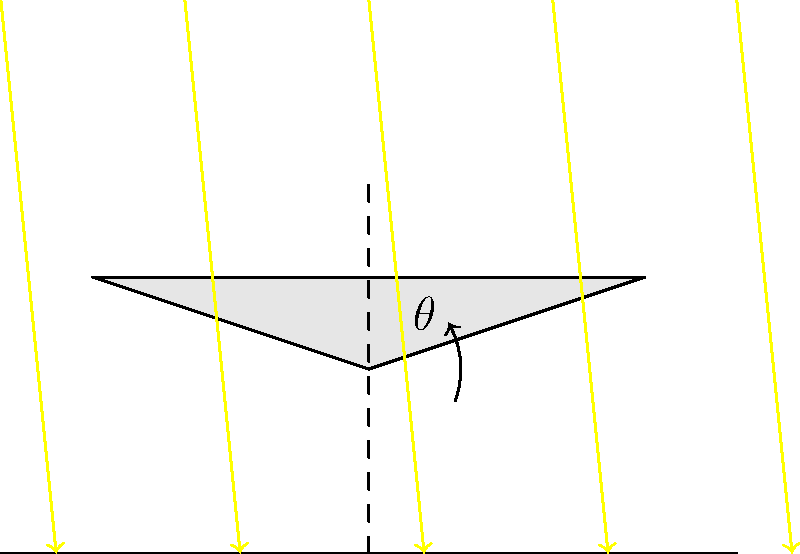A solar panel array is designed to rotate around a central axis to maximize energy capture throughout the day. The panel's efficiency is proportional to $\cos(\alpha)$, where $\alpha$ is the angle between the sun's rays and the normal to the panel's surface. If the sun's elevation angle is $30°$ above the horizon, at what angle $\theta$ should the panel be tilted from the horizontal to maximize energy capture? To maximize energy capture, we need to minimize the angle $\alpha$ between the sun's rays and the normal to the panel's surface. Ideally, we want $\alpha = 0°$, which means the panel should be perpendicular to the sun's rays.

Step 1: Understand the relationship between angles
The sun's elevation angle is $30°$ above the horizon. The panel's tilt angle $\theta$ is measured from the horizontal.

Step 2: Determine the condition for perpendicularity
For the panel to be perpendicular to the sun's rays, the panel's tilt angle $\theta$ should be equal to the sun's elevation angle.

Step 3: Set up the equation
$\theta = 30°$

Step 4: Verify the solution
When $\theta = 30°$, the panel will be perfectly perpendicular to the sun's rays, minimizing $\alpha$ to 0° and maximizing $\cos(\alpha)$ to 1, which gives the highest efficiency.

Therefore, the optimal tilt angle $\theta$ for the solar panel is $30°$ from the horizontal.
Answer: $30°$ 